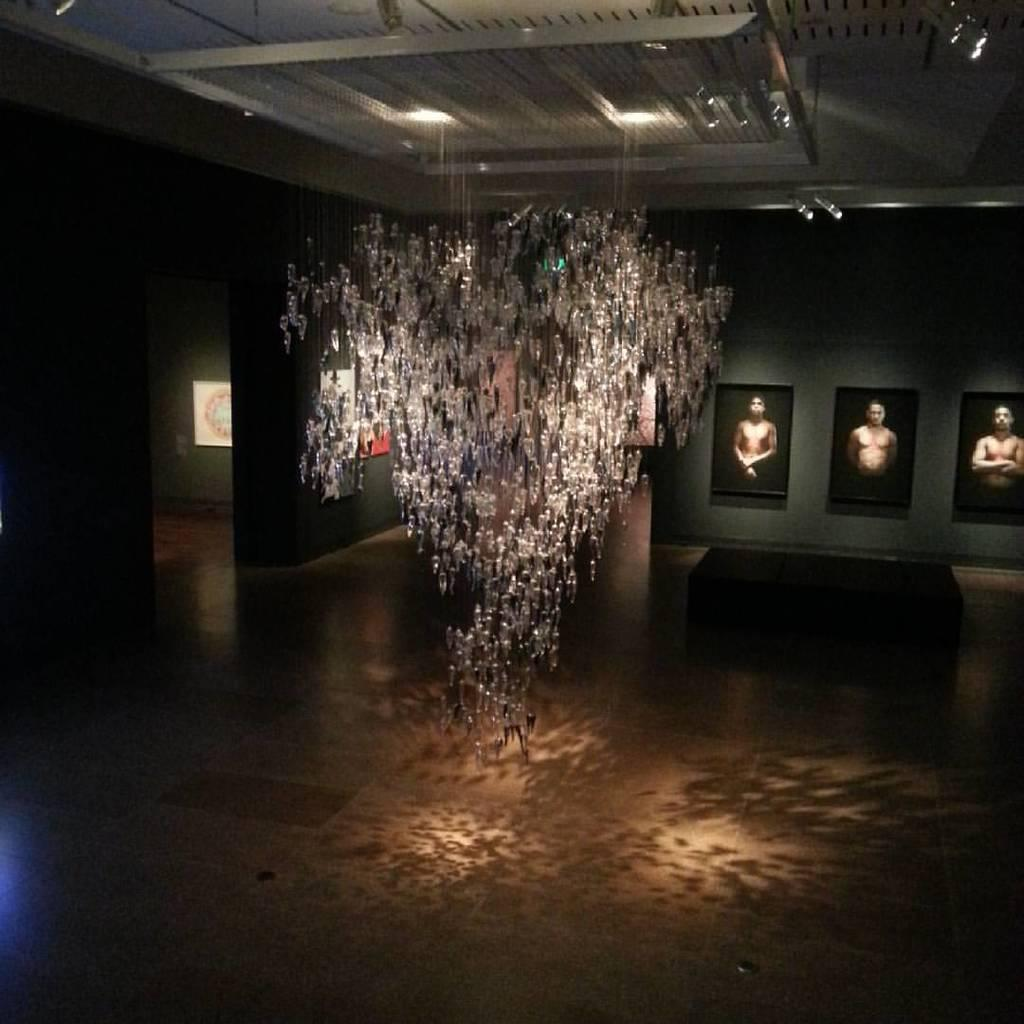What is attached to the wall in the image? There are picture frames attached to the wall in the image. What type of lighting fixture is present in the image? A lamp is hanged from the roof in the image. How many legs can be seen supporting the lamp in the image? There are no legs visible in the image; the lamp is hanged from the roof. Are there any rings present in the image? There is no mention of rings in the provided facts, so we cannot determine if any are present in the image. 